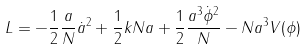<formula> <loc_0><loc_0><loc_500><loc_500>L = - \frac { 1 } { 2 } \frac { a } { N } \dot { a } ^ { 2 } + \frac { 1 } { 2 } k N a + \frac { 1 } { 2 } \frac { a ^ { 3 } \dot { \phi } ^ { 2 } } { N } - N a ^ { 3 } V ( \phi )</formula> 